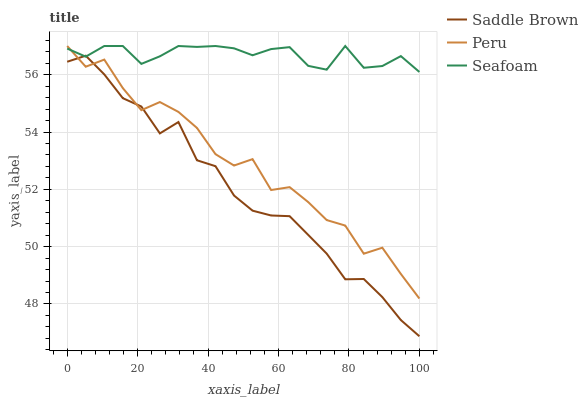Does Saddle Brown have the minimum area under the curve?
Answer yes or no. Yes. Does Seafoam have the maximum area under the curve?
Answer yes or no. Yes. Does Peru have the minimum area under the curve?
Answer yes or no. No. Does Peru have the maximum area under the curve?
Answer yes or no. No. Is Seafoam the smoothest?
Answer yes or no. Yes. Is Peru the roughest?
Answer yes or no. Yes. Is Peru the smoothest?
Answer yes or no. No. Is Seafoam the roughest?
Answer yes or no. No. Does Saddle Brown have the lowest value?
Answer yes or no. Yes. Does Peru have the lowest value?
Answer yes or no. No. Does Seafoam have the highest value?
Answer yes or no. Yes. Does Seafoam intersect Saddle Brown?
Answer yes or no. Yes. Is Seafoam less than Saddle Brown?
Answer yes or no. No. Is Seafoam greater than Saddle Brown?
Answer yes or no. No. 